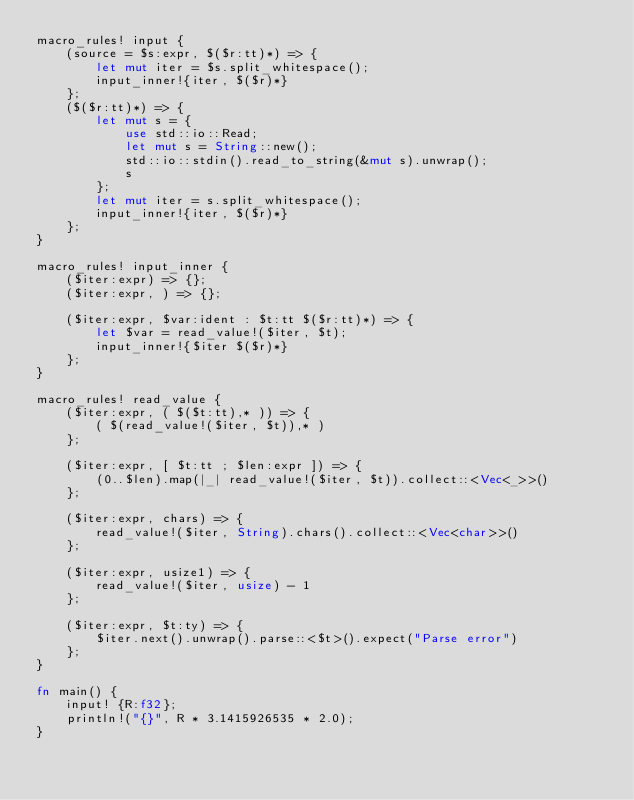<code> <loc_0><loc_0><loc_500><loc_500><_Rust_>macro_rules! input {
    (source = $s:expr, $($r:tt)*) => {
        let mut iter = $s.split_whitespace();
        input_inner!{iter, $($r)*}
    };
    ($($r:tt)*) => {
        let mut s = {
            use std::io::Read;
            let mut s = String::new();
            std::io::stdin().read_to_string(&mut s).unwrap();
            s
        };
        let mut iter = s.split_whitespace();
        input_inner!{iter, $($r)*}
    };
}

macro_rules! input_inner {
    ($iter:expr) => {};
    ($iter:expr, ) => {};

    ($iter:expr, $var:ident : $t:tt $($r:tt)*) => {
        let $var = read_value!($iter, $t);
        input_inner!{$iter $($r)*}
    };
}

macro_rules! read_value {
    ($iter:expr, ( $($t:tt),* )) => {
        ( $(read_value!($iter, $t)),* )
    };

    ($iter:expr, [ $t:tt ; $len:expr ]) => {
        (0..$len).map(|_| read_value!($iter, $t)).collect::<Vec<_>>()
    };

    ($iter:expr, chars) => {
        read_value!($iter, String).chars().collect::<Vec<char>>()
    };

    ($iter:expr, usize1) => {
        read_value!($iter, usize) - 1
    };

    ($iter:expr, $t:ty) => {
        $iter.next().unwrap().parse::<$t>().expect("Parse error")
    };
}

fn main() {
    input! {R:f32};
    println!("{}", R * 3.1415926535 * 2.0);
}
</code> 